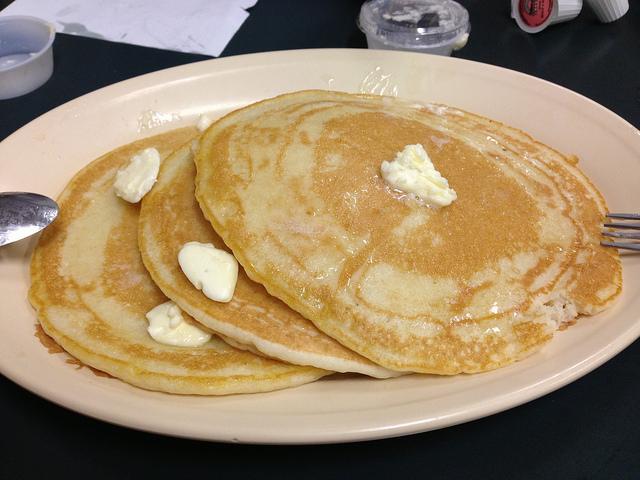Is this meal hot?
Short answer required. Yes. What color is the plate?
Short answer required. White. What is on the pancakes?
Keep it brief. Butter. Are there mushrooms on the plate?
Be succinct. No. Can you read the brand of creamer?
Keep it brief. No. How many different types of doughnuts are there?
Answer briefly. 0. What course is this?
Keep it brief. Breakfast. What is made of metal?
Concise answer only. Silverware. What kind of food is this?
Keep it brief. Pancakes. How many pancakes are on the plate?
Answer briefly. 3. What is the plate made out of?
Answer briefly. Ceramic. Is there chocolate mousse on the plate?
Be succinct. No. What is the round food on the plate?
Keep it brief. Pancake. Does the meal look sweat?
Give a very brief answer. Yes. What restaurant is this at?
Give a very brief answer. Ihop. What color are the cakes?
Write a very short answer. Brown. What is topping the pancakes?
Quick response, please. Butter. What kind of pancake is this?
Quick response, please. Buttermilk. Is this dish traditional for the occasion?
Write a very short answer. Yes. 